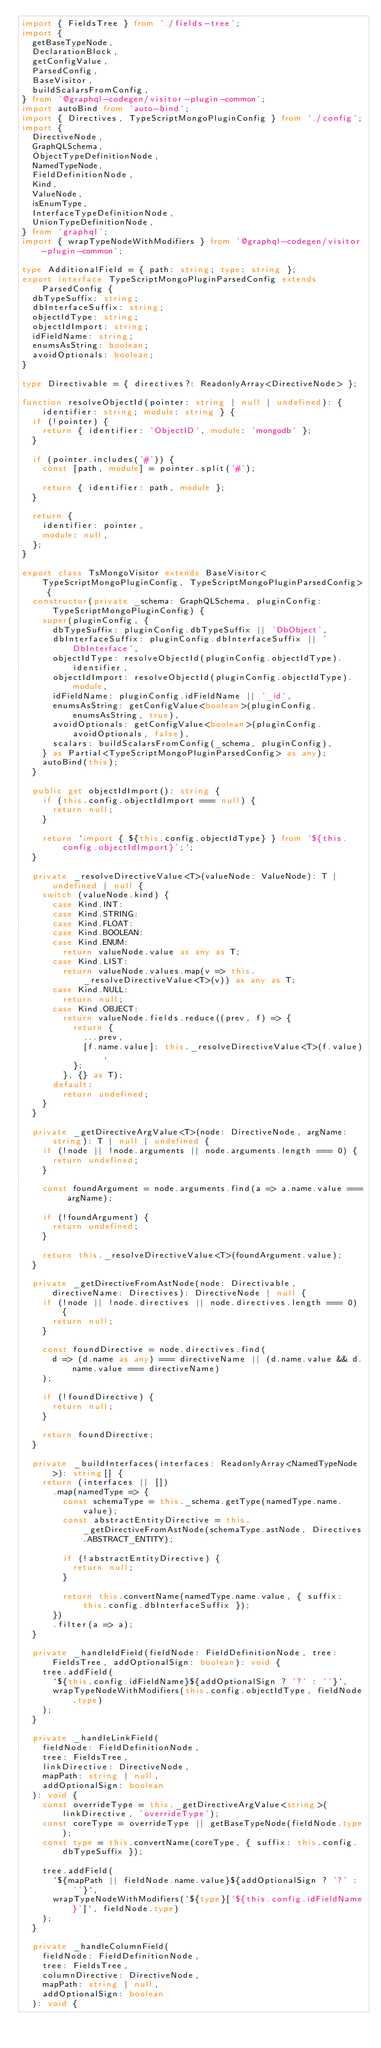Convert code to text. <code><loc_0><loc_0><loc_500><loc_500><_TypeScript_>import { FieldsTree } from './fields-tree';
import {
  getBaseTypeNode,
  DeclarationBlock,
  getConfigValue,
  ParsedConfig,
  BaseVisitor,
  buildScalarsFromConfig,
} from '@graphql-codegen/visitor-plugin-common';
import autoBind from 'auto-bind';
import { Directives, TypeScriptMongoPluginConfig } from './config';
import {
  DirectiveNode,
  GraphQLSchema,
  ObjectTypeDefinitionNode,
  NamedTypeNode,
  FieldDefinitionNode,
  Kind,
  ValueNode,
  isEnumType,
  InterfaceTypeDefinitionNode,
  UnionTypeDefinitionNode,
} from 'graphql';
import { wrapTypeNodeWithModifiers } from '@graphql-codegen/visitor-plugin-common';

type AdditionalField = { path: string; type: string };
export interface TypeScriptMongoPluginParsedConfig extends ParsedConfig {
  dbTypeSuffix: string;
  dbInterfaceSuffix: string;
  objectIdType: string;
  objectIdImport: string;
  idFieldName: string;
  enumsAsString: boolean;
  avoidOptionals: boolean;
}

type Directivable = { directives?: ReadonlyArray<DirectiveNode> };

function resolveObjectId(pointer: string | null | undefined): { identifier: string; module: string } {
  if (!pointer) {
    return { identifier: 'ObjectID', module: 'mongodb' };
  }

  if (pointer.includes('#')) {
    const [path, module] = pointer.split('#');

    return { identifier: path, module };
  }

  return {
    identifier: pointer,
    module: null,
  };
}

export class TsMongoVisitor extends BaseVisitor<TypeScriptMongoPluginConfig, TypeScriptMongoPluginParsedConfig> {
  constructor(private _schema: GraphQLSchema, pluginConfig: TypeScriptMongoPluginConfig) {
    super(pluginConfig, {
      dbTypeSuffix: pluginConfig.dbTypeSuffix || 'DbObject',
      dbInterfaceSuffix: pluginConfig.dbInterfaceSuffix || 'DbInterface',
      objectIdType: resolveObjectId(pluginConfig.objectIdType).identifier,
      objectIdImport: resolveObjectId(pluginConfig.objectIdType).module,
      idFieldName: pluginConfig.idFieldName || '_id',
      enumsAsString: getConfigValue<boolean>(pluginConfig.enumsAsString, true),
      avoidOptionals: getConfigValue<boolean>(pluginConfig.avoidOptionals, false),
      scalars: buildScalarsFromConfig(_schema, pluginConfig),
    } as Partial<TypeScriptMongoPluginParsedConfig> as any);
    autoBind(this);
  }

  public get objectIdImport(): string {
    if (this.config.objectIdImport === null) {
      return null;
    }

    return `import { ${this.config.objectIdType} } from '${this.config.objectIdImport}';`;
  }

  private _resolveDirectiveValue<T>(valueNode: ValueNode): T | undefined | null {
    switch (valueNode.kind) {
      case Kind.INT:
      case Kind.STRING:
      case Kind.FLOAT:
      case Kind.BOOLEAN:
      case Kind.ENUM:
        return valueNode.value as any as T;
      case Kind.LIST:
        return valueNode.values.map(v => this._resolveDirectiveValue<T>(v)) as any as T;
      case Kind.NULL:
        return null;
      case Kind.OBJECT:
        return valueNode.fields.reduce((prev, f) => {
          return {
            ...prev,
            [f.name.value]: this._resolveDirectiveValue<T>(f.value),
          };
        }, {} as T);
      default:
        return undefined;
    }
  }

  private _getDirectiveArgValue<T>(node: DirectiveNode, argName: string): T | null | undefined {
    if (!node || !node.arguments || node.arguments.length === 0) {
      return undefined;
    }

    const foundArgument = node.arguments.find(a => a.name.value === argName);

    if (!foundArgument) {
      return undefined;
    }

    return this._resolveDirectiveValue<T>(foundArgument.value);
  }

  private _getDirectiveFromAstNode(node: Directivable, directiveName: Directives): DirectiveNode | null {
    if (!node || !node.directives || node.directives.length === 0) {
      return null;
    }

    const foundDirective = node.directives.find(
      d => (d.name as any) === directiveName || (d.name.value && d.name.value === directiveName)
    );

    if (!foundDirective) {
      return null;
    }

    return foundDirective;
  }

  private _buildInterfaces(interfaces: ReadonlyArray<NamedTypeNode>): string[] {
    return (interfaces || [])
      .map(namedType => {
        const schemaType = this._schema.getType(namedType.name.value);
        const abstractEntityDirective = this._getDirectiveFromAstNode(schemaType.astNode, Directives.ABSTRACT_ENTITY);

        if (!abstractEntityDirective) {
          return null;
        }

        return this.convertName(namedType.name.value, { suffix: this.config.dbInterfaceSuffix });
      })
      .filter(a => a);
  }

  private _handleIdField(fieldNode: FieldDefinitionNode, tree: FieldsTree, addOptionalSign: boolean): void {
    tree.addField(
      `${this.config.idFieldName}${addOptionalSign ? '?' : ''}`,
      wrapTypeNodeWithModifiers(this.config.objectIdType, fieldNode.type)
    );
  }

  private _handleLinkField(
    fieldNode: FieldDefinitionNode,
    tree: FieldsTree,
    linkDirective: DirectiveNode,
    mapPath: string | null,
    addOptionalSign: boolean
  ): void {
    const overrideType = this._getDirectiveArgValue<string>(linkDirective, 'overrideType');
    const coreType = overrideType || getBaseTypeNode(fieldNode.type);
    const type = this.convertName(coreType, { suffix: this.config.dbTypeSuffix });

    tree.addField(
      `${mapPath || fieldNode.name.value}${addOptionalSign ? '?' : ''}`,
      wrapTypeNodeWithModifiers(`${type}['${this.config.idFieldName}']`, fieldNode.type)
    );
  }

  private _handleColumnField(
    fieldNode: FieldDefinitionNode,
    tree: FieldsTree,
    columnDirective: DirectiveNode,
    mapPath: string | null,
    addOptionalSign: boolean
  ): void {</code> 